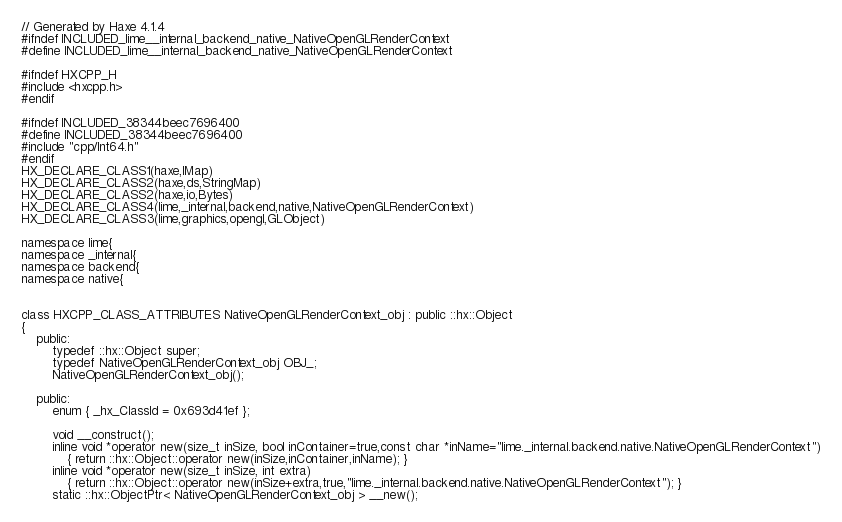<code> <loc_0><loc_0><loc_500><loc_500><_C_>// Generated by Haxe 4.1.4
#ifndef INCLUDED_lime__internal_backend_native_NativeOpenGLRenderContext
#define INCLUDED_lime__internal_backend_native_NativeOpenGLRenderContext

#ifndef HXCPP_H
#include <hxcpp.h>
#endif

#ifndef INCLUDED_38344beec7696400
#define INCLUDED_38344beec7696400
#include "cpp/Int64.h"
#endif
HX_DECLARE_CLASS1(haxe,IMap)
HX_DECLARE_CLASS2(haxe,ds,StringMap)
HX_DECLARE_CLASS2(haxe,io,Bytes)
HX_DECLARE_CLASS4(lime,_internal,backend,native,NativeOpenGLRenderContext)
HX_DECLARE_CLASS3(lime,graphics,opengl,GLObject)

namespace lime{
namespace _internal{
namespace backend{
namespace native{


class HXCPP_CLASS_ATTRIBUTES NativeOpenGLRenderContext_obj : public ::hx::Object
{
	public:
		typedef ::hx::Object super;
		typedef NativeOpenGLRenderContext_obj OBJ_;
		NativeOpenGLRenderContext_obj();

	public:
		enum { _hx_ClassId = 0x693d41ef };

		void __construct();
		inline void *operator new(size_t inSize, bool inContainer=true,const char *inName="lime._internal.backend.native.NativeOpenGLRenderContext")
			{ return ::hx::Object::operator new(inSize,inContainer,inName); }
		inline void *operator new(size_t inSize, int extra)
			{ return ::hx::Object::operator new(inSize+extra,true,"lime._internal.backend.native.NativeOpenGLRenderContext"); }
		static ::hx::ObjectPtr< NativeOpenGLRenderContext_obj > __new();</code> 